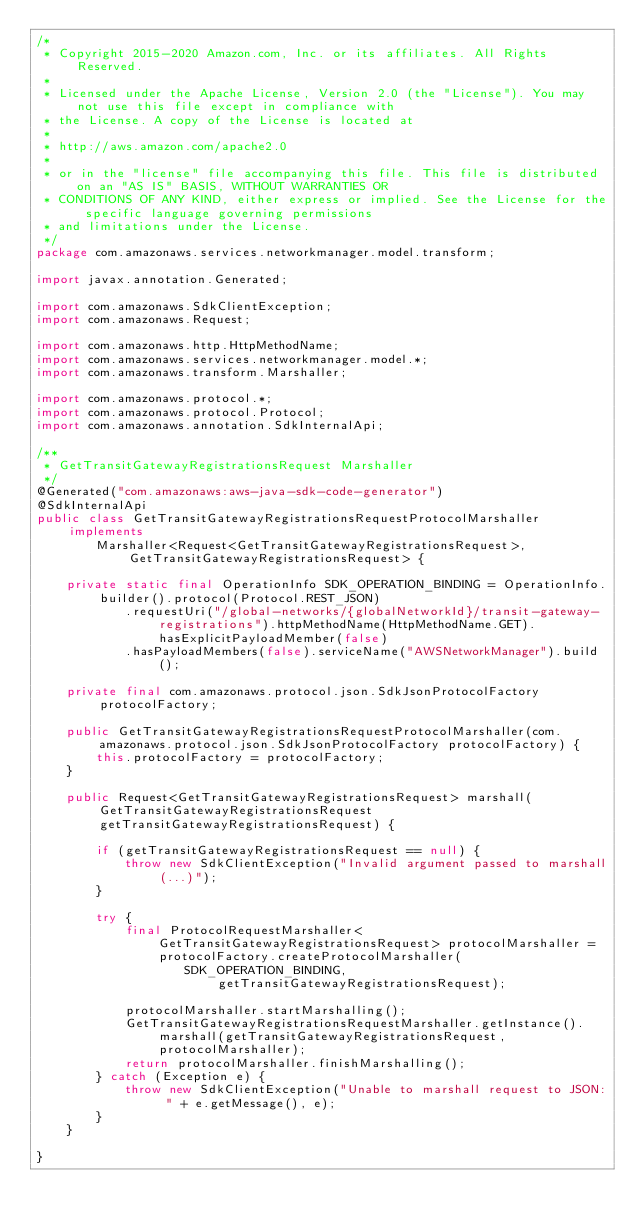<code> <loc_0><loc_0><loc_500><loc_500><_Java_>/*
 * Copyright 2015-2020 Amazon.com, Inc. or its affiliates. All Rights Reserved.
 * 
 * Licensed under the Apache License, Version 2.0 (the "License"). You may not use this file except in compliance with
 * the License. A copy of the License is located at
 * 
 * http://aws.amazon.com/apache2.0
 * 
 * or in the "license" file accompanying this file. This file is distributed on an "AS IS" BASIS, WITHOUT WARRANTIES OR
 * CONDITIONS OF ANY KIND, either express or implied. See the License for the specific language governing permissions
 * and limitations under the License.
 */
package com.amazonaws.services.networkmanager.model.transform;

import javax.annotation.Generated;

import com.amazonaws.SdkClientException;
import com.amazonaws.Request;

import com.amazonaws.http.HttpMethodName;
import com.amazonaws.services.networkmanager.model.*;
import com.amazonaws.transform.Marshaller;

import com.amazonaws.protocol.*;
import com.amazonaws.protocol.Protocol;
import com.amazonaws.annotation.SdkInternalApi;

/**
 * GetTransitGatewayRegistrationsRequest Marshaller
 */
@Generated("com.amazonaws:aws-java-sdk-code-generator")
@SdkInternalApi
public class GetTransitGatewayRegistrationsRequestProtocolMarshaller implements
        Marshaller<Request<GetTransitGatewayRegistrationsRequest>, GetTransitGatewayRegistrationsRequest> {

    private static final OperationInfo SDK_OPERATION_BINDING = OperationInfo.builder().protocol(Protocol.REST_JSON)
            .requestUri("/global-networks/{globalNetworkId}/transit-gateway-registrations").httpMethodName(HttpMethodName.GET).hasExplicitPayloadMember(false)
            .hasPayloadMembers(false).serviceName("AWSNetworkManager").build();

    private final com.amazonaws.protocol.json.SdkJsonProtocolFactory protocolFactory;

    public GetTransitGatewayRegistrationsRequestProtocolMarshaller(com.amazonaws.protocol.json.SdkJsonProtocolFactory protocolFactory) {
        this.protocolFactory = protocolFactory;
    }

    public Request<GetTransitGatewayRegistrationsRequest> marshall(GetTransitGatewayRegistrationsRequest getTransitGatewayRegistrationsRequest) {

        if (getTransitGatewayRegistrationsRequest == null) {
            throw new SdkClientException("Invalid argument passed to marshall(...)");
        }

        try {
            final ProtocolRequestMarshaller<GetTransitGatewayRegistrationsRequest> protocolMarshaller = protocolFactory.createProtocolMarshaller(
                    SDK_OPERATION_BINDING, getTransitGatewayRegistrationsRequest);

            protocolMarshaller.startMarshalling();
            GetTransitGatewayRegistrationsRequestMarshaller.getInstance().marshall(getTransitGatewayRegistrationsRequest, protocolMarshaller);
            return protocolMarshaller.finishMarshalling();
        } catch (Exception e) {
            throw new SdkClientException("Unable to marshall request to JSON: " + e.getMessage(), e);
        }
    }

}
</code> 